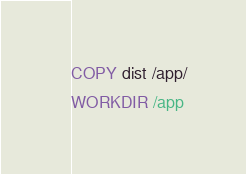<code> <loc_0><loc_0><loc_500><loc_500><_Dockerfile_>
COPY dist /app/
WORKDIR /app
</code> 